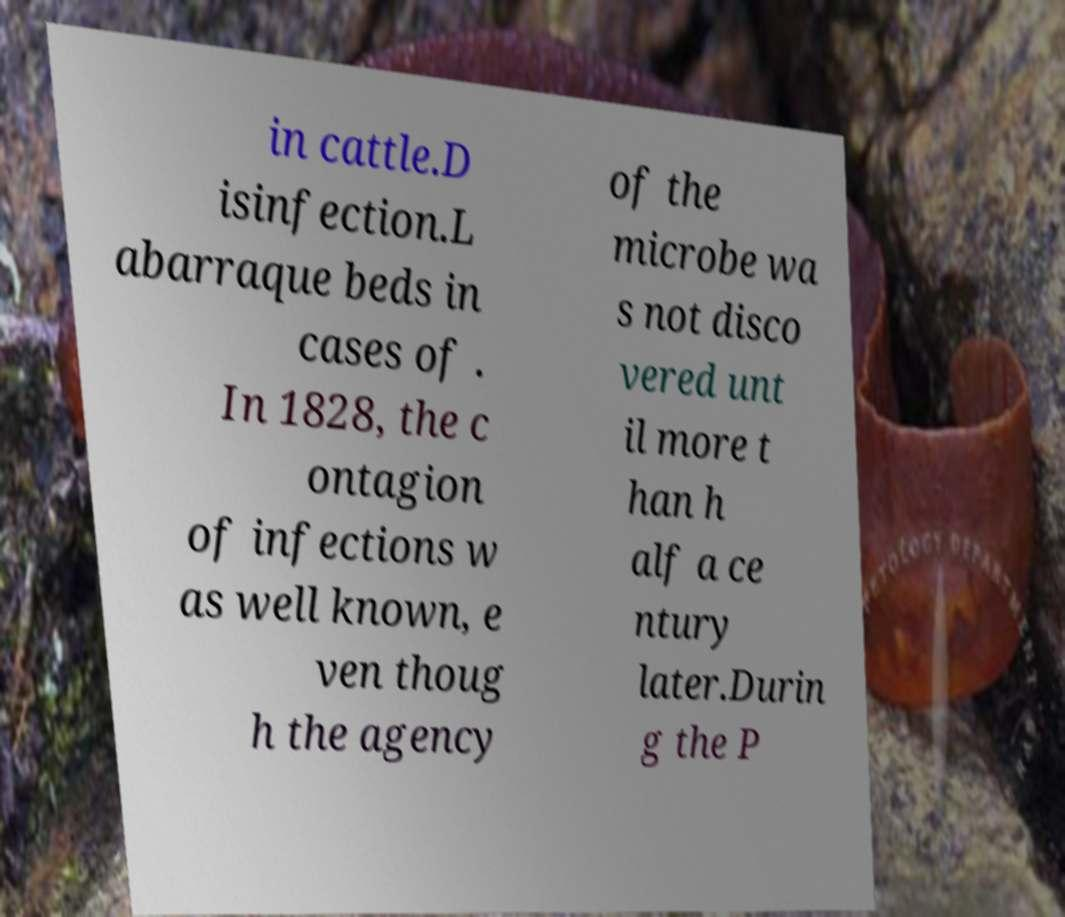What messages or text are displayed in this image? I need them in a readable, typed format. in cattle.D isinfection.L abarraque beds in cases of . In 1828, the c ontagion of infections w as well known, e ven thoug h the agency of the microbe wa s not disco vered unt il more t han h alf a ce ntury later.Durin g the P 